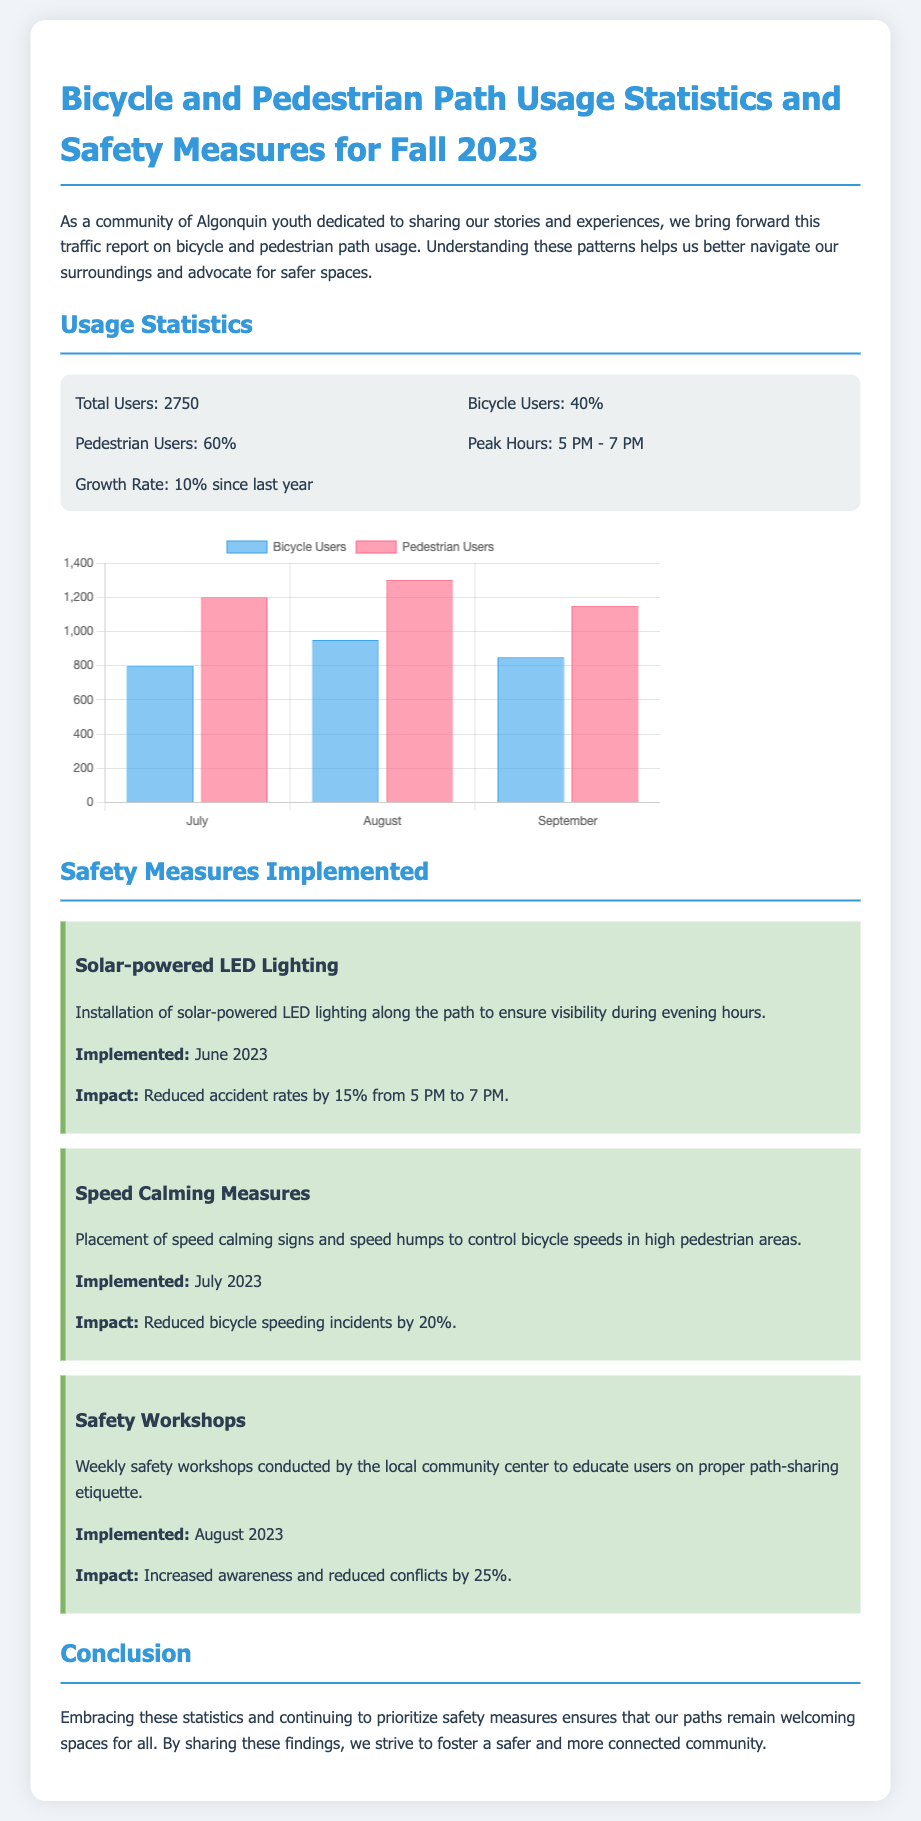What is the total number of users? The total number of users is provided in the statistics section. It is stated as 2750.
Answer: 2750 What percentage of users are pedestrians? The document specifies the distribution of users, indicating that 60% are pedestrians.
Answer: 60% When were safety workshops implemented? The implementation date of safety workshops is mentioned, which is August 2023.
Answer: August 2023 What was the impact of the solar-powered LED lighting? The effect of the installed lighting is discussed in the safety measures section, noting a reduction in accident rates by 15%.
Answer: 15% What are the peak hours of path usage? The document outlines the busiest times for path usage, noting peak hours are between 5 PM and 7 PM.
Answer: 5 PM - 7 PM How much did bicycle speeding incidents decrease? The document details the effectiveness of speed calming measures, reporting a 20% reduction in speeding incidents.
Answer: 20% What was the growth rate in user numbers since last year? The growth rate mentioned in the statistics section indicates a 10% increase since the previous year.
Answer: 10% What type of lighting was implemented for safety? The specific type of lighting discussed in the safety measures section is solar-powered LED lighting.
Answer: Solar-powered LED Lighting What type of report is this document? The document is classified as a traffic report, specifically focusing on bicycle and pedestrian path usage.
Answer: Traffic report 